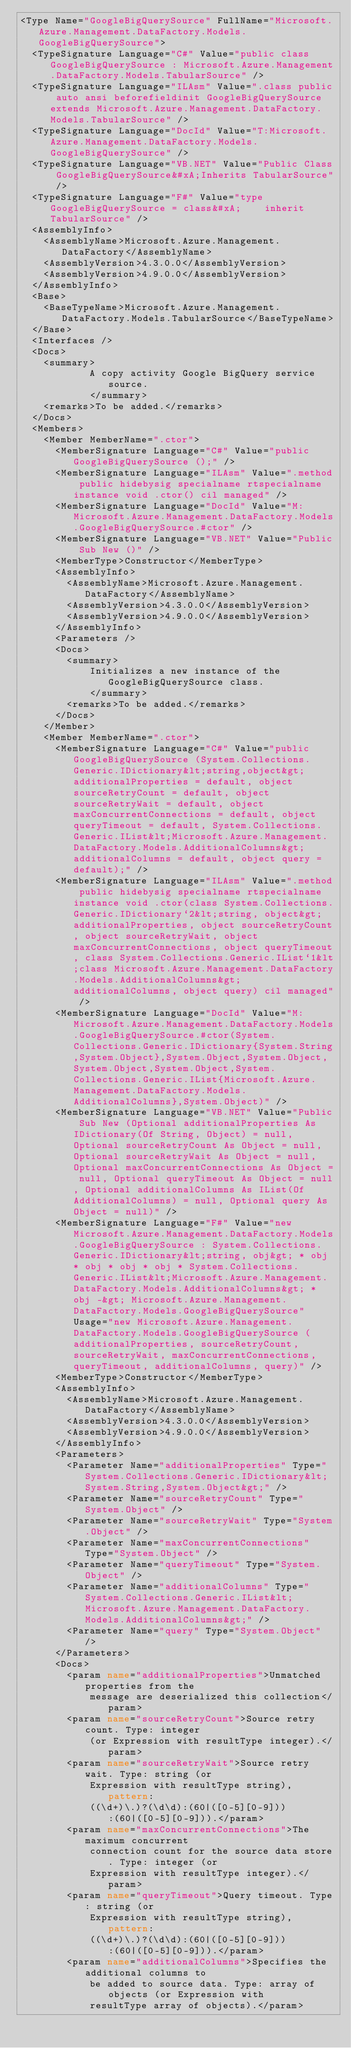Convert code to text. <code><loc_0><loc_0><loc_500><loc_500><_XML_><Type Name="GoogleBigQuerySource" FullName="Microsoft.Azure.Management.DataFactory.Models.GoogleBigQuerySource">
  <TypeSignature Language="C#" Value="public class GoogleBigQuerySource : Microsoft.Azure.Management.DataFactory.Models.TabularSource" />
  <TypeSignature Language="ILAsm" Value=".class public auto ansi beforefieldinit GoogleBigQuerySource extends Microsoft.Azure.Management.DataFactory.Models.TabularSource" />
  <TypeSignature Language="DocId" Value="T:Microsoft.Azure.Management.DataFactory.Models.GoogleBigQuerySource" />
  <TypeSignature Language="VB.NET" Value="Public Class GoogleBigQuerySource&#xA;Inherits TabularSource" />
  <TypeSignature Language="F#" Value="type GoogleBigQuerySource = class&#xA;    inherit TabularSource" />
  <AssemblyInfo>
    <AssemblyName>Microsoft.Azure.Management.DataFactory</AssemblyName>
    <AssemblyVersion>4.3.0.0</AssemblyVersion>
    <AssemblyVersion>4.9.0.0</AssemblyVersion>
  </AssemblyInfo>
  <Base>
    <BaseTypeName>Microsoft.Azure.Management.DataFactory.Models.TabularSource</BaseTypeName>
  </Base>
  <Interfaces />
  <Docs>
    <summary>
            A copy activity Google BigQuery service source.
            </summary>
    <remarks>To be added.</remarks>
  </Docs>
  <Members>
    <Member MemberName=".ctor">
      <MemberSignature Language="C#" Value="public GoogleBigQuerySource ();" />
      <MemberSignature Language="ILAsm" Value=".method public hidebysig specialname rtspecialname instance void .ctor() cil managed" />
      <MemberSignature Language="DocId" Value="M:Microsoft.Azure.Management.DataFactory.Models.GoogleBigQuerySource.#ctor" />
      <MemberSignature Language="VB.NET" Value="Public Sub New ()" />
      <MemberType>Constructor</MemberType>
      <AssemblyInfo>
        <AssemblyName>Microsoft.Azure.Management.DataFactory</AssemblyName>
        <AssemblyVersion>4.3.0.0</AssemblyVersion>
        <AssemblyVersion>4.9.0.0</AssemblyVersion>
      </AssemblyInfo>
      <Parameters />
      <Docs>
        <summary>
            Initializes a new instance of the GoogleBigQuerySource class.
            </summary>
        <remarks>To be added.</remarks>
      </Docs>
    </Member>
    <Member MemberName=".ctor">
      <MemberSignature Language="C#" Value="public GoogleBigQuerySource (System.Collections.Generic.IDictionary&lt;string,object&gt; additionalProperties = default, object sourceRetryCount = default, object sourceRetryWait = default, object maxConcurrentConnections = default, object queryTimeout = default, System.Collections.Generic.IList&lt;Microsoft.Azure.Management.DataFactory.Models.AdditionalColumns&gt; additionalColumns = default, object query = default);" />
      <MemberSignature Language="ILAsm" Value=".method public hidebysig specialname rtspecialname instance void .ctor(class System.Collections.Generic.IDictionary`2&lt;string, object&gt; additionalProperties, object sourceRetryCount, object sourceRetryWait, object maxConcurrentConnections, object queryTimeout, class System.Collections.Generic.IList`1&lt;class Microsoft.Azure.Management.DataFactory.Models.AdditionalColumns&gt; additionalColumns, object query) cil managed" />
      <MemberSignature Language="DocId" Value="M:Microsoft.Azure.Management.DataFactory.Models.GoogleBigQuerySource.#ctor(System.Collections.Generic.IDictionary{System.String,System.Object},System.Object,System.Object,System.Object,System.Object,System.Collections.Generic.IList{Microsoft.Azure.Management.DataFactory.Models.AdditionalColumns},System.Object)" />
      <MemberSignature Language="VB.NET" Value="Public Sub New (Optional additionalProperties As IDictionary(Of String, Object) = null, Optional sourceRetryCount As Object = null, Optional sourceRetryWait As Object = null, Optional maxConcurrentConnections As Object = null, Optional queryTimeout As Object = null, Optional additionalColumns As IList(Of AdditionalColumns) = null, Optional query As Object = null)" />
      <MemberSignature Language="F#" Value="new Microsoft.Azure.Management.DataFactory.Models.GoogleBigQuerySource : System.Collections.Generic.IDictionary&lt;string, obj&gt; * obj * obj * obj * obj * System.Collections.Generic.IList&lt;Microsoft.Azure.Management.DataFactory.Models.AdditionalColumns&gt; * obj -&gt; Microsoft.Azure.Management.DataFactory.Models.GoogleBigQuerySource" Usage="new Microsoft.Azure.Management.DataFactory.Models.GoogleBigQuerySource (additionalProperties, sourceRetryCount, sourceRetryWait, maxConcurrentConnections, queryTimeout, additionalColumns, query)" />
      <MemberType>Constructor</MemberType>
      <AssemblyInfo>
        <AssemblyName>Microsoft.Azure.Management.DataFactory</AssemblyName>
        <AssemblyVersion>4.3.0.0</AssemblyVersion>
        <AssemblyVersion>4.9.0.0</AssemblyVersion>
      </AssemblyInfo>
      <Parameters>
        <Parameter Name="additionalProperties" Type="System.Collections.Generic.IDictionary&lt;System.String,System.Object&gt;" />
        <Parameter Name="sourceRetryCount" Type="System.Object" />
        <Parameter Name="sourceRetryWait" Type="System.Object" />
        <Parameter Name="maxConcurrentConnections" Type="System.Object" />
        <Parameter Name="queryTimeout" Type="System.Object" />
        <Parameter Name="additionalColumns" Type="System.Collections.Generic.IList&lt;Microsoft.Azure.Management.DataFactory.Models.AdditionalColumns&gt;" />
        <Parameter Name="query" Type="System.Object" />
      </Parameters>
      <Docs>
        <param name="additionalProperties">Unmatched properties from the
            message are deserialized this collection</param>
        <param name="sourceRetryCount">Source retry count. Type: integer
            (or Expression with resultType integer).</param>
        <param name="sourceRetryWait">Source retry wait. Type: string (or
            Expression with resultType string), pattern:
            ((\d+)\.)?(\d\d):(60|([0-5][0-9])):(60|([0-5][0-9])).</param>
        <param name="maxConcurrentConnections">The maximum concurrent
            connection count for the source data store. Type: integer (or
            Expression with resultType integer).</param>
        <param name="queryTimeout">Query timeout. Type: string (or
            Expression with resultType string), pattern:
            ((\d+)\.)?(\d\d):(60|([0-5][0-9])):(60|([0-5][0-9])).</param>
        <param name="additionalColumns">Specifies the additional columns to
            be added to source data. Type: array of objects (or Expression with
            resultType array of objects).</param></code> 